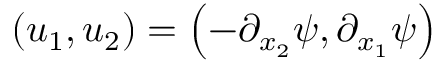Convert formula to latex. <formula><loc_0><loc_0><loc_500><loc_500>\left ( u _ { 1 } , u _ { 2 } \right ) = \left ( - \partial _ { x _ { 2 } } \psi , \partial _ { x _ { 1 } } \psi \right )</formula> 